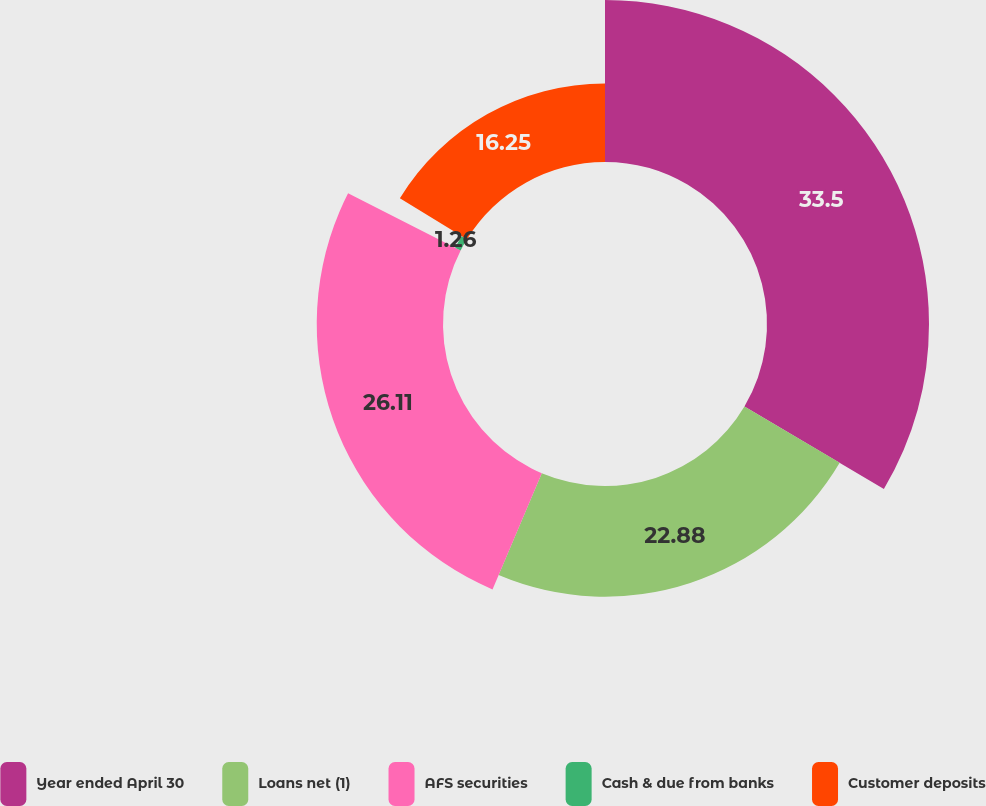<chart> <loc_0><loc_0><loc_500><loc_500><pie_chart><fcel>Year ended April 30<fcel>Loans net (1)<fcel>AFS securities<fcel>Cash & due from banks<fcel>Customer deposits<nl><fcel>33.5%<fcel>22.88%<fcel>26.11%<fcel>1.26%<fcel>16.25%<nl></chart> 